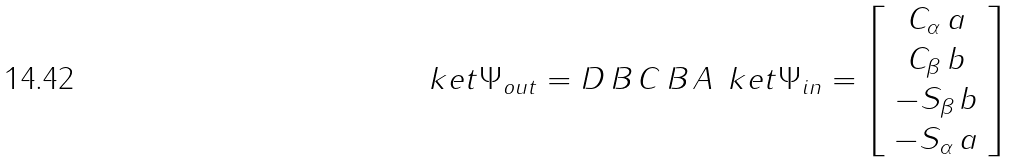Convert formula to latex. <formula><loc_0><loc_0><loc_500><loc_500>\ k e t { \Psi _ { o u t } } = D \, B \, C \, B \, A \, \ k e t { \Psi _ { i n } } = \left [ \begin{array} { c } C _ { \alpha } \, a \\ C _ { \beta } \, b \\ - S _ { \beta } \, b \\ - S _ { \alpha } \, a \end{array} \right ]</formula> 